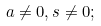Convert formula to latex. <formula><loc_0><loc_0><loc_500><loc_500>a \not = 0 , s \not = 0 ;</formula> 